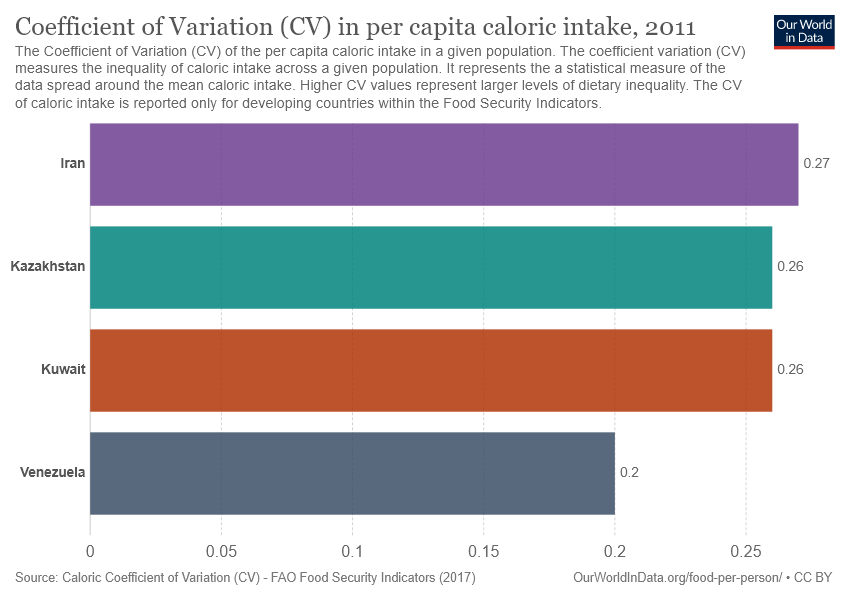Outline some significant characteristics in this image. The median value of all bars and the highest value are both important measures of a dataset's central tendency. To find the ratio of these two values, we can use the formula: ratio = (median value / highest value). In this case, the ratio is 0.9629629629629629. 